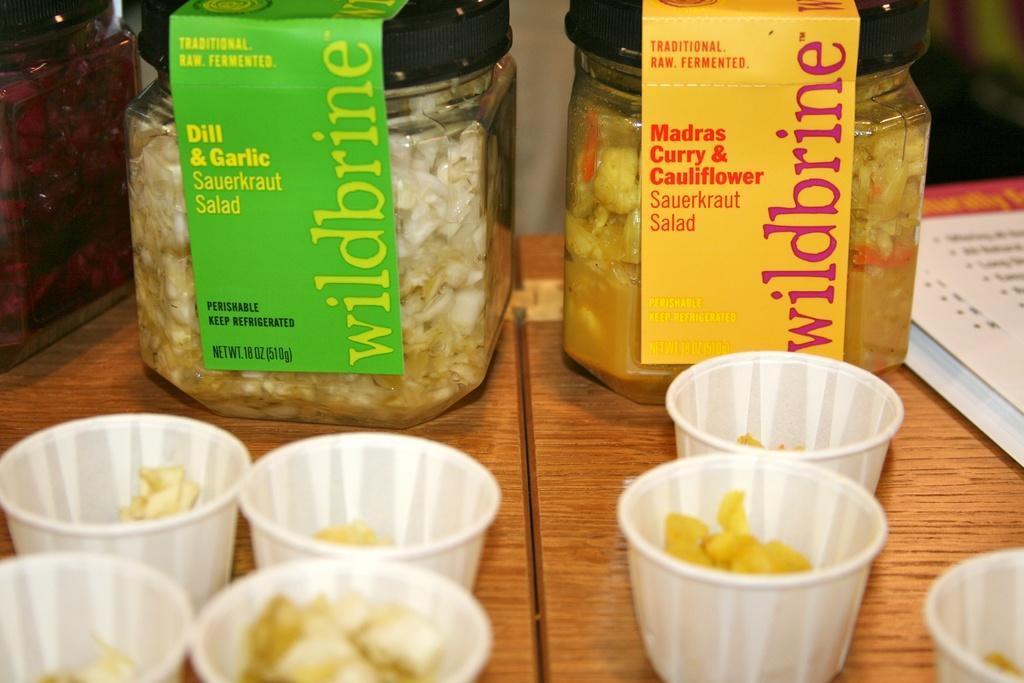Please provide a concise description of this image. In this image there is a table with two jars filled with food items beside that there is a menu card and in front of that there are some cups with food items. 